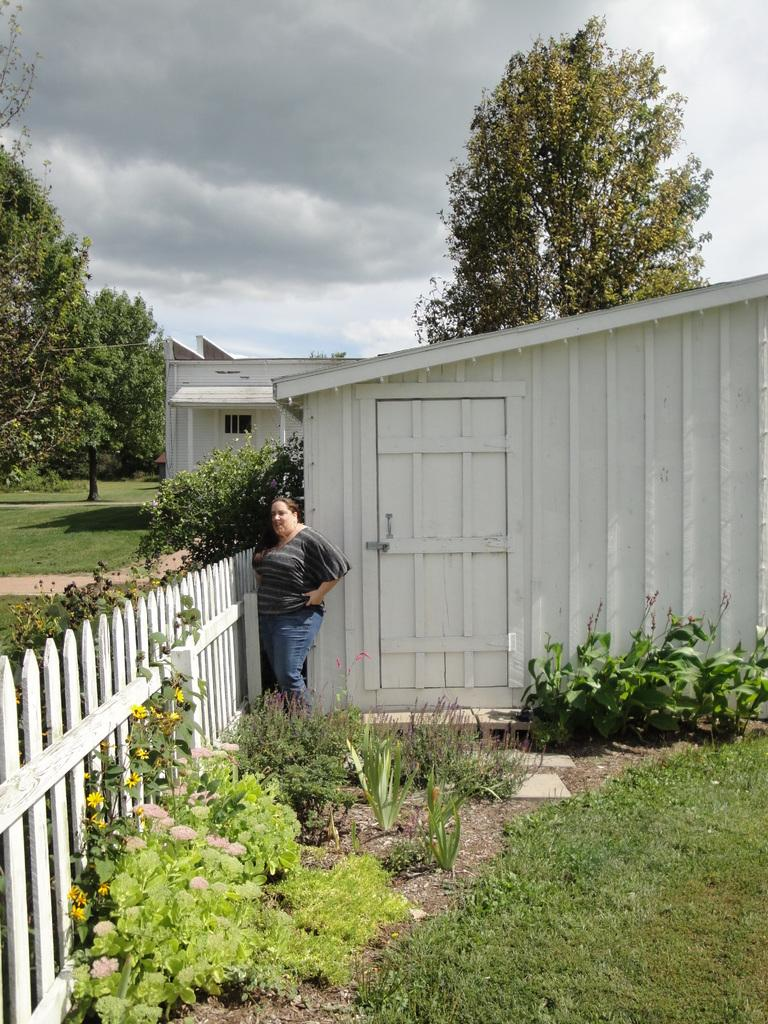What is the main subject of the image? There is a woman standing in the image. Can you describe what the woman is wearing? The woman is wearing clothes. What type of structures can be seen in the image? There is a wooden fence and a wooden house in the image. What type of natural environment is visible in the image? Grass, plants, and trees are present in the image. What type of path is visible in the image? There is a path in the image. How would you describe the sky in the image? The sky is cloudy in the image. What type of substance is being used to fill the square in the image? There is no square present in the image, and therefore no substance being used to fill it. 